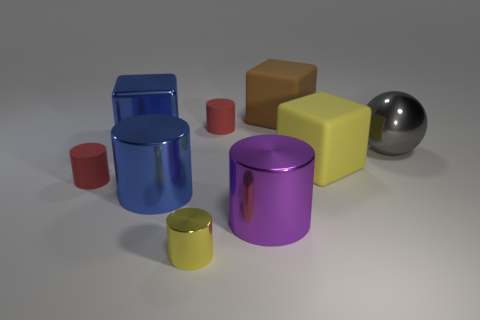Subtract 2 cylinders. How many cylinders are left? 3 Subtract all yellow cylinders. How many cylinders are left? 4 Subtract all blue cylinders. How many cylinders are left? 4 Subtract all cyan cylinders. Subtract all gray spheres. How many cylinders are left? 5 Subtract all balls. How many objects are left? 8 Add 6 large red metallic cylinders. How many large red metallic cylinders exist? 6 Subtract 1 yellow cylinders. How many objects are left? 8 Subtract all small yellow objects. Subtract all large purple shiny objects. How many objects are left? 7 Add 2 brown things. How many brown things are left? 3 